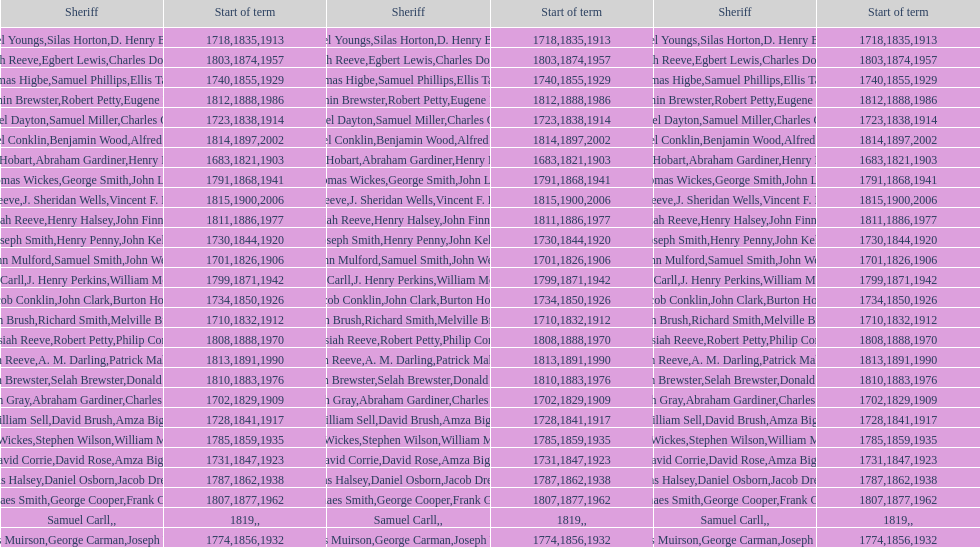What is the total number of sheriffs that were in office in suffolk county between 1903 and 1957? 17. 